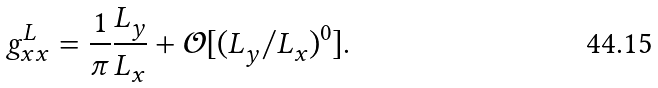<formula> <loc_0><loc_0><loc_500><loc_500>g ^ { L } _ { x x } = \frac { 1 } { \pi } \frac { L ^ { \ } _ { y } } { L ^ { \ } _ { x } } + \mathcal { O } [ ( L ^ { \ } _ { y } / L ^ { \ } _ { x } ) ^ { 0 } ] .</formula> 